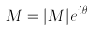<formula> <loc_0><loc_0><loc_500><loc_500>M = | M | e ^ { i \theta }</formula> 